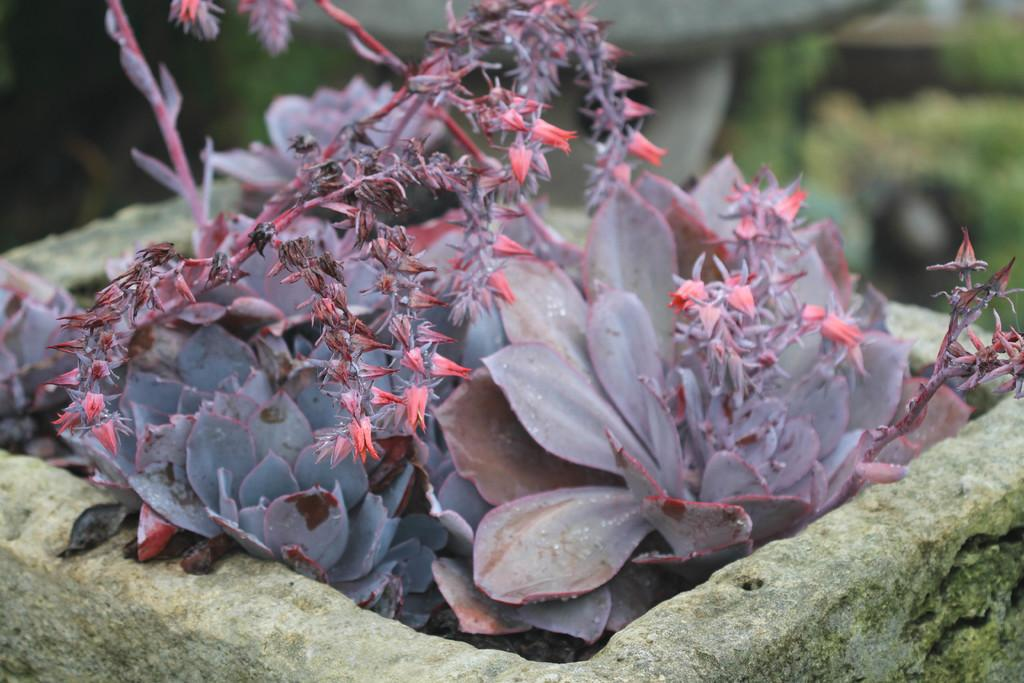What type of plant is visible in the image? There is a plant in the image. What additional feature can be seen on the plant? There are flowers in the image. What color are the flowers? The flowers are pink in color. How would you describe the background of the image? The background of the image is blurred. What type of polish is being applied to the flowers in the image? There is no polish being applied to the flowers in the image; they are simply pink flowers on a plant. 